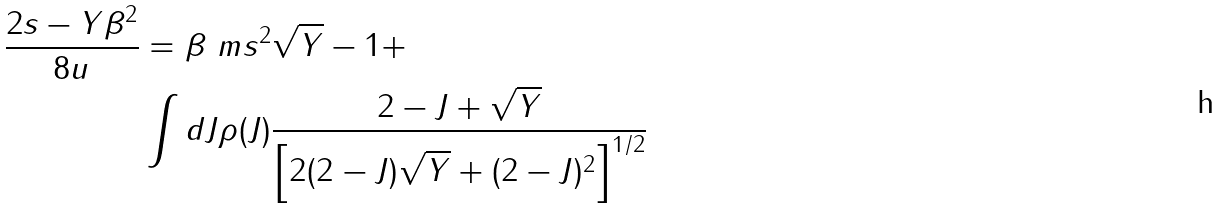Convert formula to latex. <formula><loc_0><loc_0><loc_500><loc_500>\frac { 2 s - Y \beta ^ { 2 } } { 8 u } & = \beta \ m s ^ { 2 } \sqrt { Y } - 1 + \\ & \int d J \rho ( J ) \frac { 2 - J + \sqrt { Y } } { \left [ 2 ( 2 - J ) \sqrt { Y } + ( 2 - J ) ^ { 2 } \right ] ^ { 1 / 2 } }</formula> 